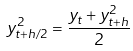<formula> <loc_0><loc_0><loc_500><loc_500>y _ { t + h / 2 } ^ { 2 } = { \frac { y _ { t } + y _ { t + h } ^ { 2 } } { 2 } }</formula> 